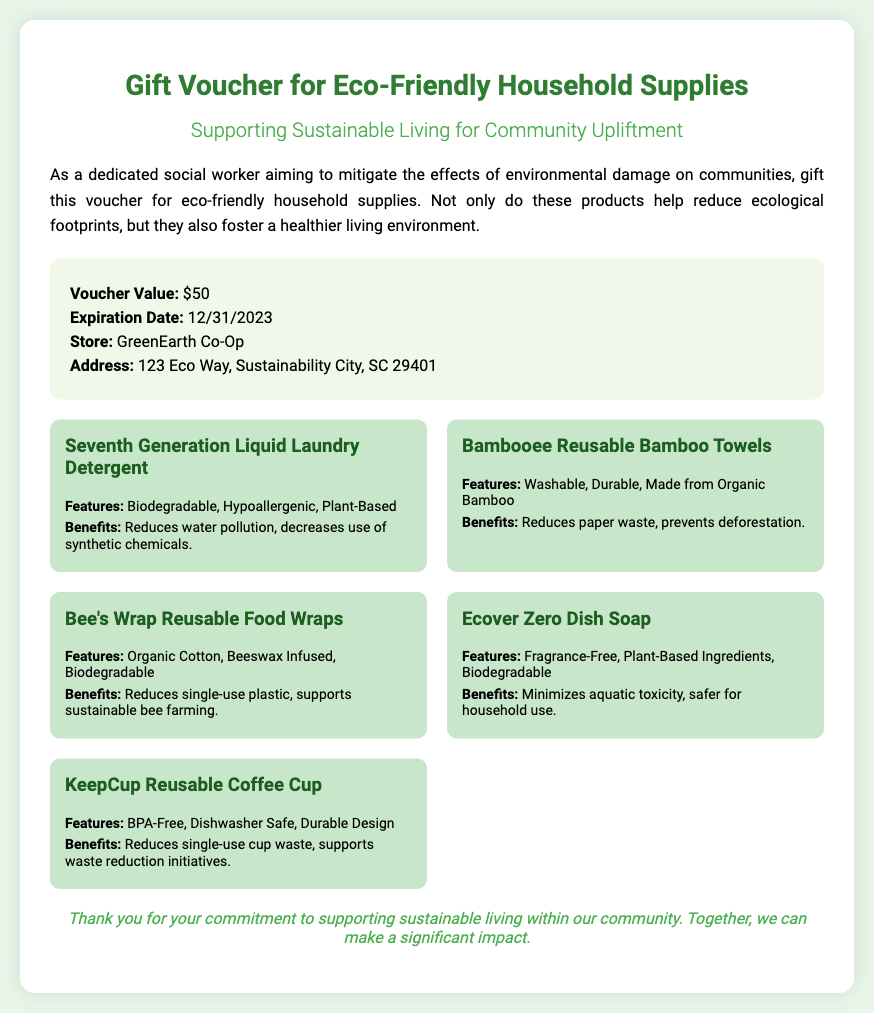What is the voucher value? The voucher value is stated in the details section of the document.
Answer: $50 What is the expiration date of the voucher? The expiration date is provided in the details section.
Answer: 12/31/2023 What store can the voucher be redeemed at? The store name is listed under the details section of the document.
Answer: GreenEarth Co-Op What is the address of the store? The address is specified in the details section of the voucher.
Answer: 123 Eco Way, Sustainability City, SC 29401 Name one benefit of Seventh Generation Liquid Laundry Detergent. This benefit is derived from the product description in the document.
Answer: Reduces water pollution What type of material are Bambooee Reusable Bamboo Towels made from? The material type is included in the features section of the product.
Answer: Organic Bamboo How does Bee's Wrap help the environment? The document details benefits that describe this impact.
Answer: Reduces single-use plastic What features does Ecover Zero Dish Soap have? The features of the product can be found in the product description.
Answer: Fragrance-Free, Plant-Based Ingredients, Biodegradable What is the message at the end of the voucher? The footer contains the message of gratitude and commitment.
Answer: Thank you for your commitment to supporting sustainable living within our community. Together, we can make a significant impact How many eco-friendly products are listed in the document? The count of products is determined by the items in the product list section.
Answer: 5 